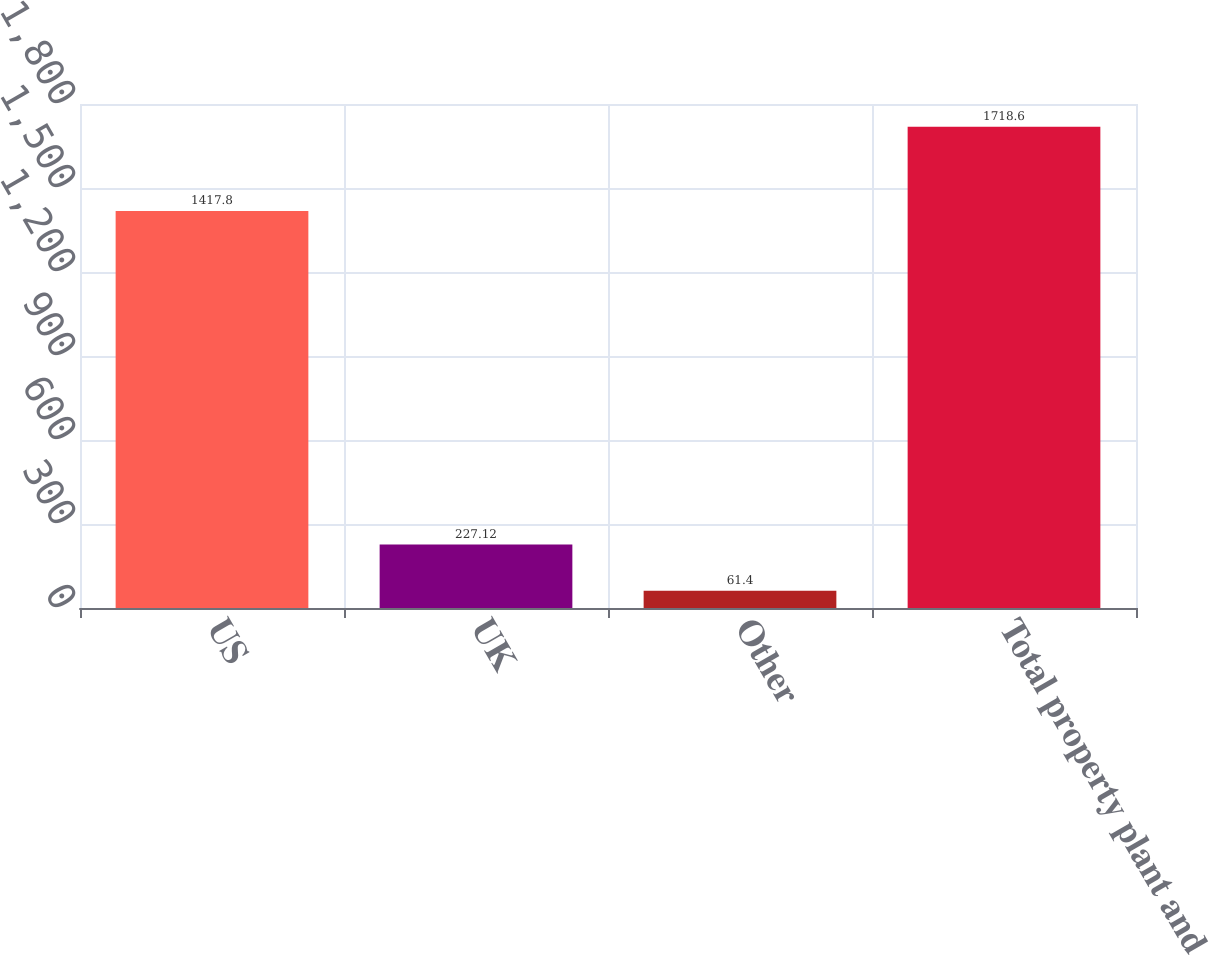Convert chart to OTSL. <chart><loc_0><loc_0><loc_500><loc_500><bar_chart><fcel>US<fcel>UK<fcel>Other<fcel>Total property plant and<nl><fcel>1417.8<fcel>227.12<fcel>61.4<fcel>1718.6<nl></chart> 